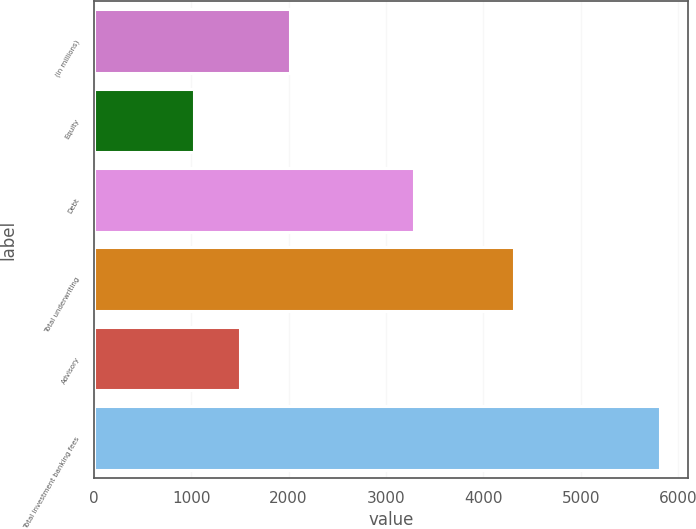Convert chart. <chart><loc_0><loc_0><loc_500><loc_500><bar_chart><fcel>(in millions)<fcel>Equity<fcel>Debt<fcel>Total underwriting<fcel>Advisory<fcel>Total investment banking fees<nl><fcel>2012<fcel>1026<fcel>3290<fcel>4316<fcel>1504.2<fcel>5808<nl></chart> 